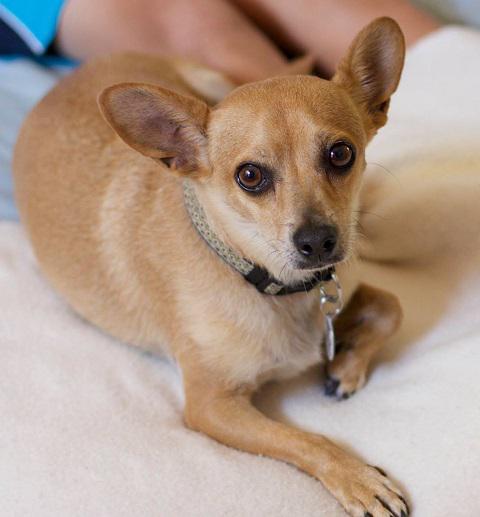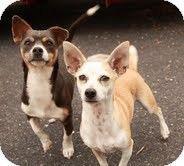The first image is the image on the left, the second image is the image on the right. Analyze the images presented: Is the assertion "The dog in the image on the left has a white collar." valid? Answer yes or no. No. 